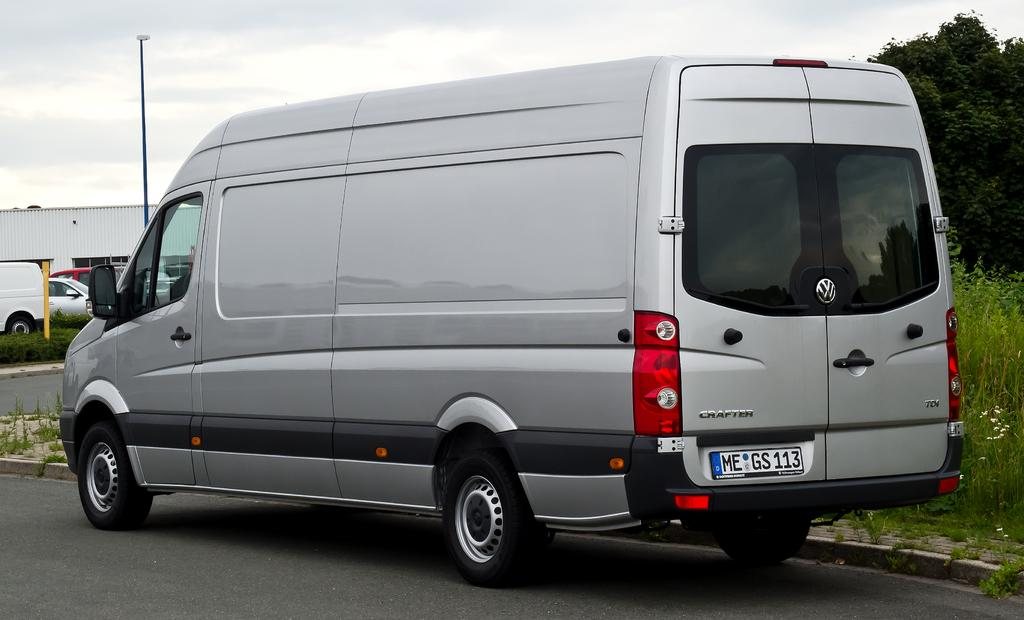<image>
Relay a brief, clear account of the picture shown. Silver van with a license plate that says MEGS113. 